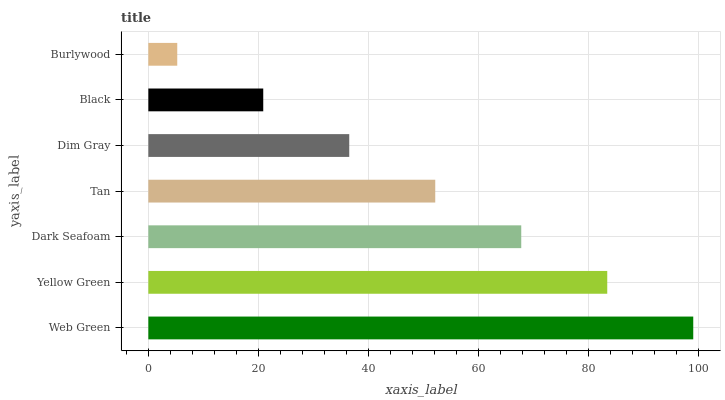Is Burlywood the minimum?
Answer yes or no. Yes. Is Web Green the maximum?
Answer yes or no. Yes. Is Yellow Green the minimum?
Answer yes or no. No. Is Yellow Green the maximum?
Answer yes or no. No. Is Web Green greater than Yellow Green?
Answer yes or no. Yes. Is Yellow Green less than Web Green?
Answer yes or no. Yes. Is Yellow Green greater than Web Green?
Answer yes or no. No. Is Web Green less than Yellow Green?
Answer yes or no. No. Is Tan the high median?
Answer yes or no. Yes. Is Tan the low median?
Answer yes or no. Yes. Is Black the high median?
Answer yes or no. No. Is Burlywood the low median?
Answer yes or no. No. 